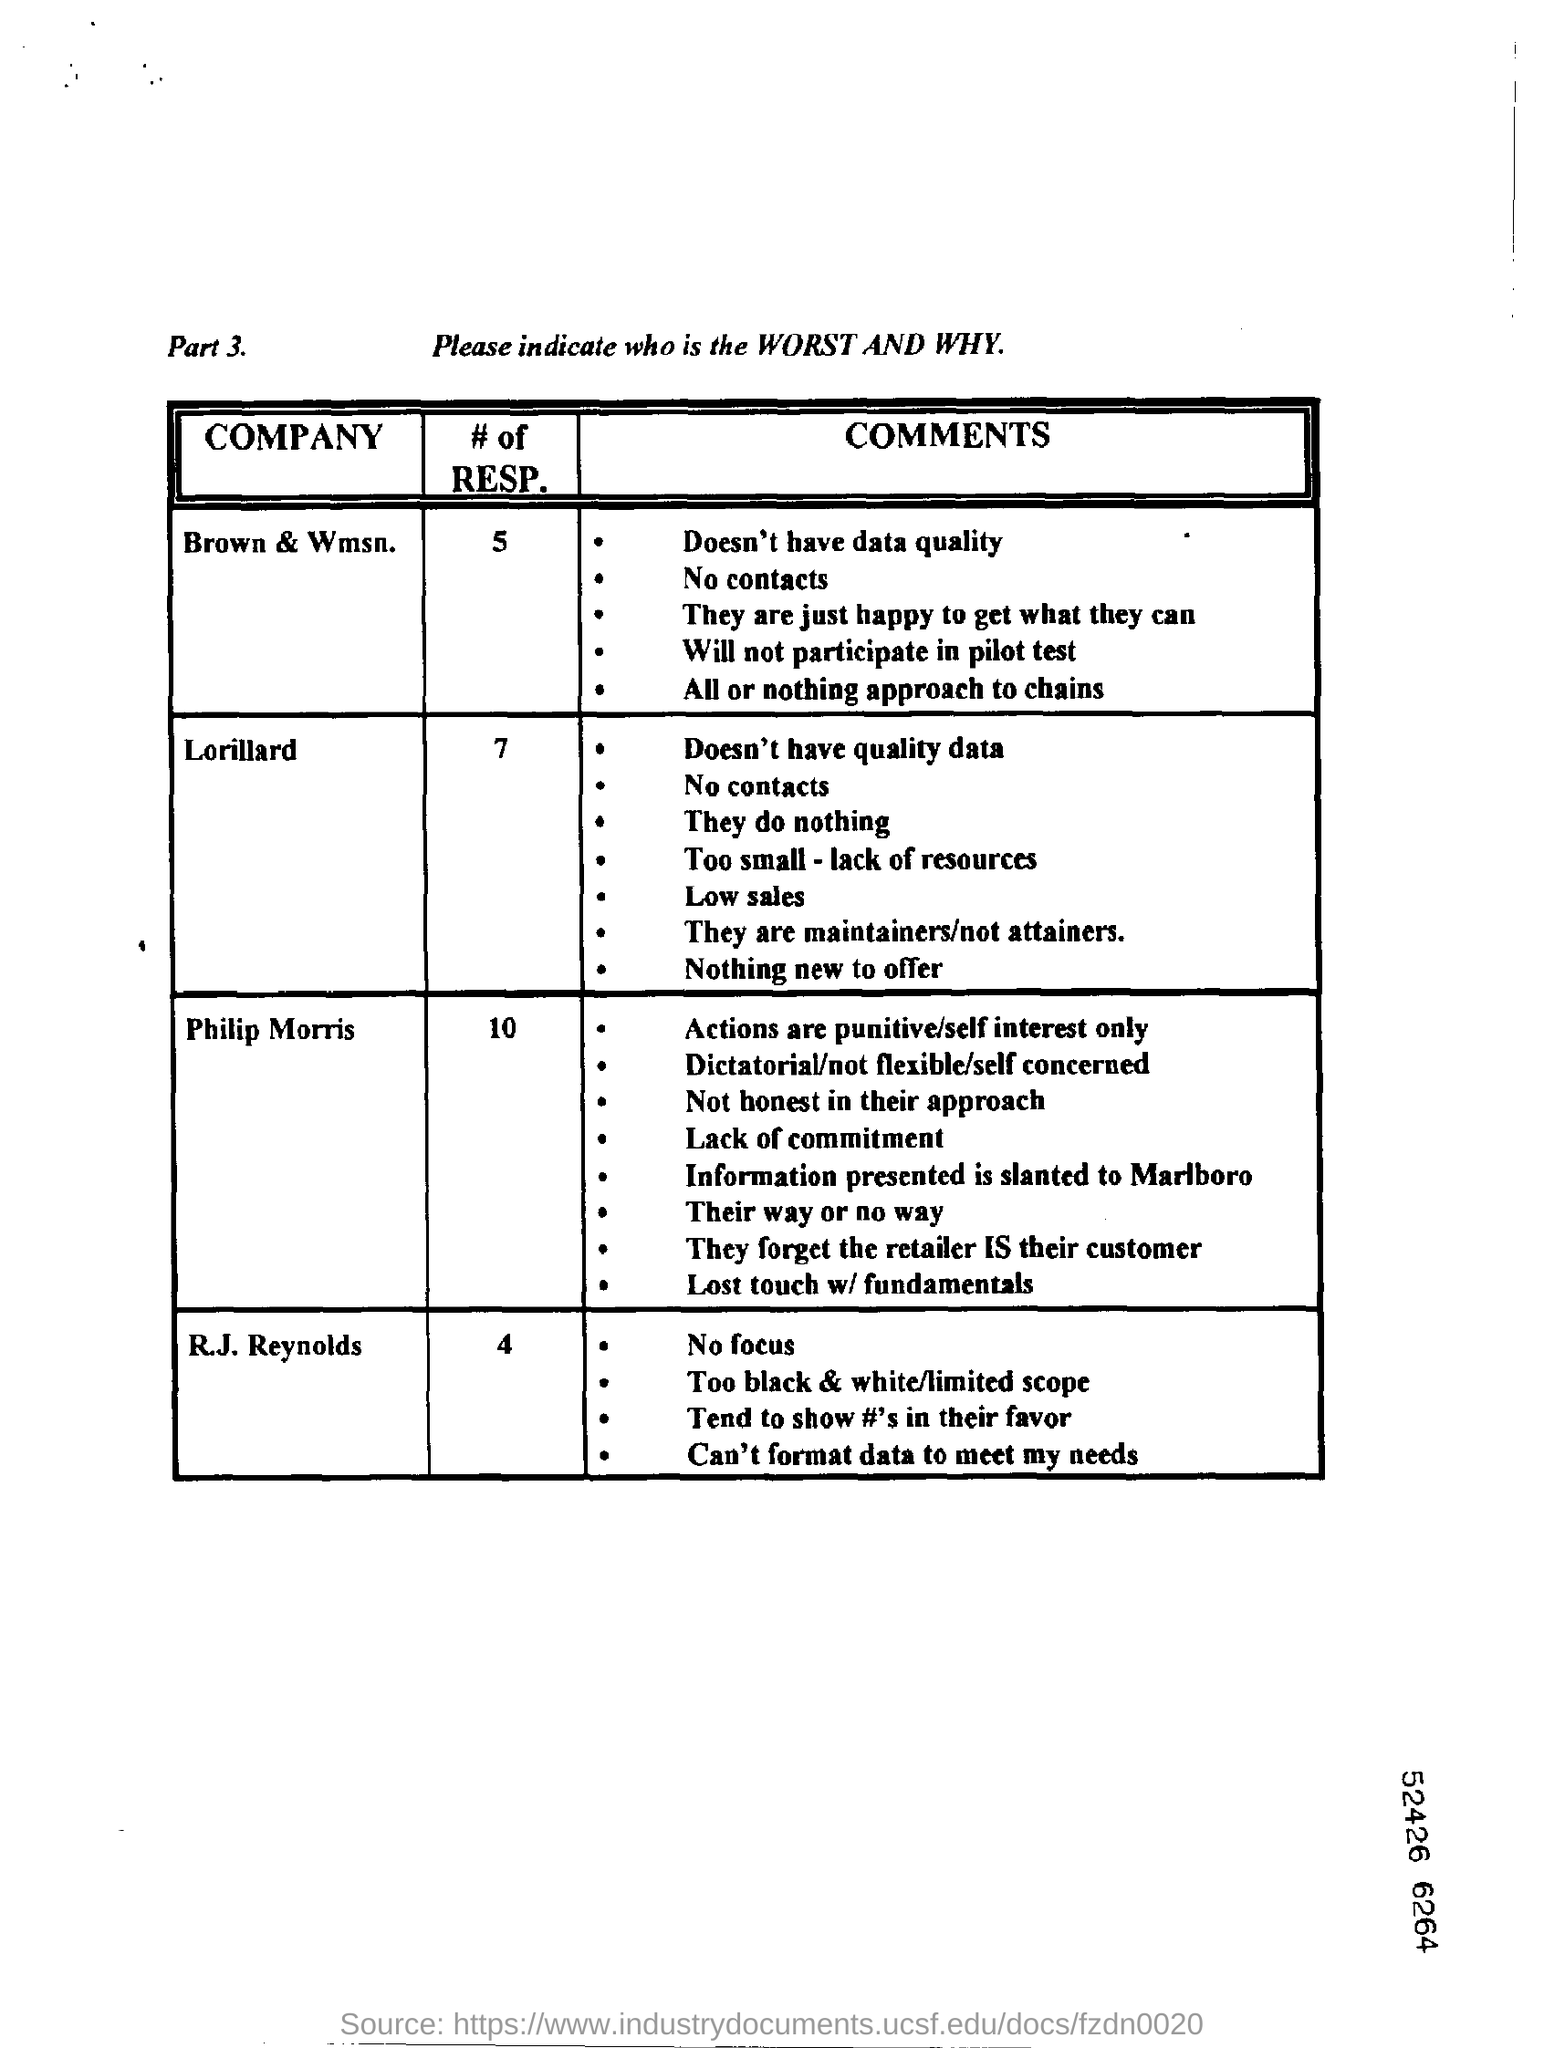Specify some key components in this picture. It is expected that Brown & WMSN will not participate in the pilot test. Philip Morris' actions are exclusively punitive and driven by self-interest. 